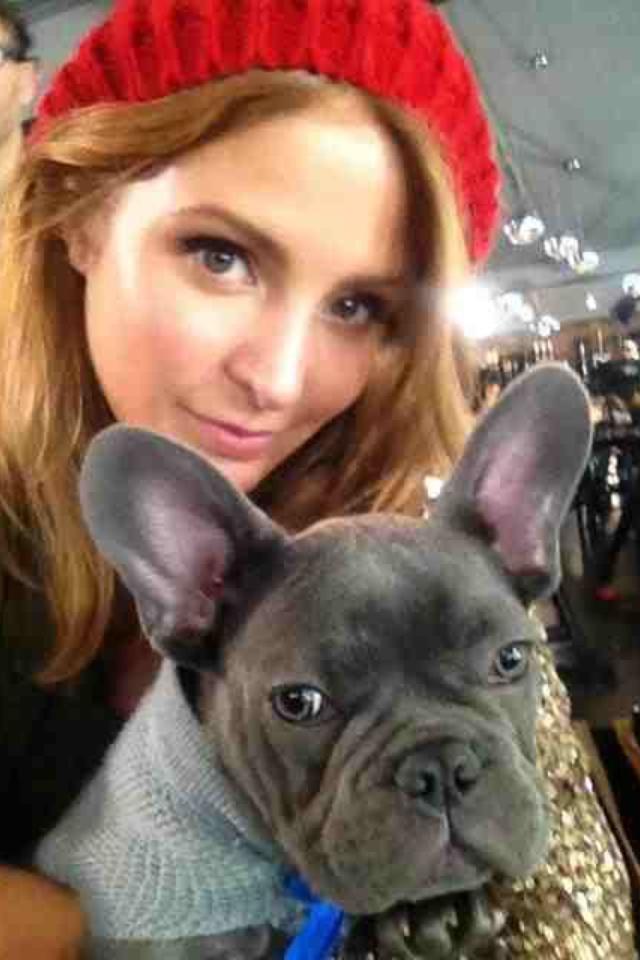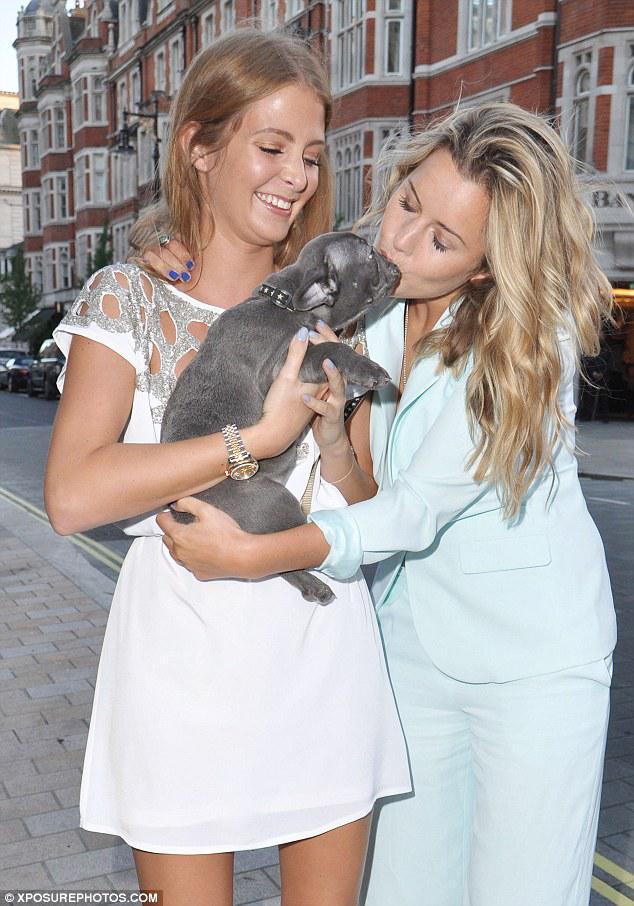The first image is the image on the left, the second image is the image on the right. Assess this claim about the two images: "Each image shows just one woman standing with an arm around a dark gray bulldog, and the same woman is shown in both images.". Correct or not? Answer yes or no. No. The first image is the image on the left, the second image is the image on the right. Given the left and right images, does the statement "Both images in the pair show exactly one woman carrying a dog in her arms." hold true? Answer yes or no. No. 